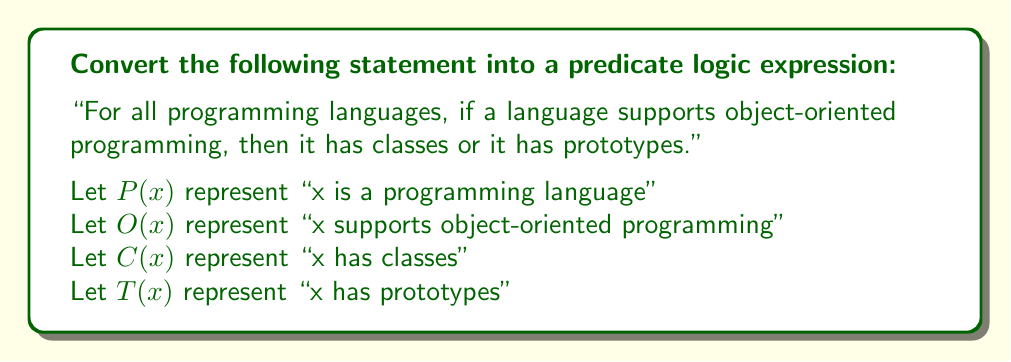Could you help me with this problem? To convert this statement into predicate logic, we'll follow these steps:

1. Identify the universal quantifier: "For all programming languages" indicates we need to use $\forall x$ (for all x).

2. Identify the main implication: "if a language supports object-oriented programming, then it has classes or it has prototypes." This forms an if-then statement, which we represent with $\rightarrow$.

3. Break down the consequent of the implication: "it has classes or it has prototypes" is a disjunction (OR statement), which we represent with $\lor$.

4. Construct the expression:
   - Start with the universal quantifier: $\forall x$
   - Add the domain condition: $P(x)$, to specify that x is a programming language
   - Add the implication: $O(x) \rightarrow (C(x) \lor T(x))$

5. Combine all parts:
   $\forall x (P(x) \rightarrow (O(x) \rightarrow (C(x) \lor T(x))))$

This expression reads as: "For all x, if x is a programming language, then if x supports object-oriented programming, then x has classes or x has prototypes."

Note that we've used parentheses to clearly show the structure of the logical expression, especially the nested implications.
Answer: $$\forall x (P(x) \rightarrow (O(x) \rightarrow (C(x) \lor T(x))))$$ 